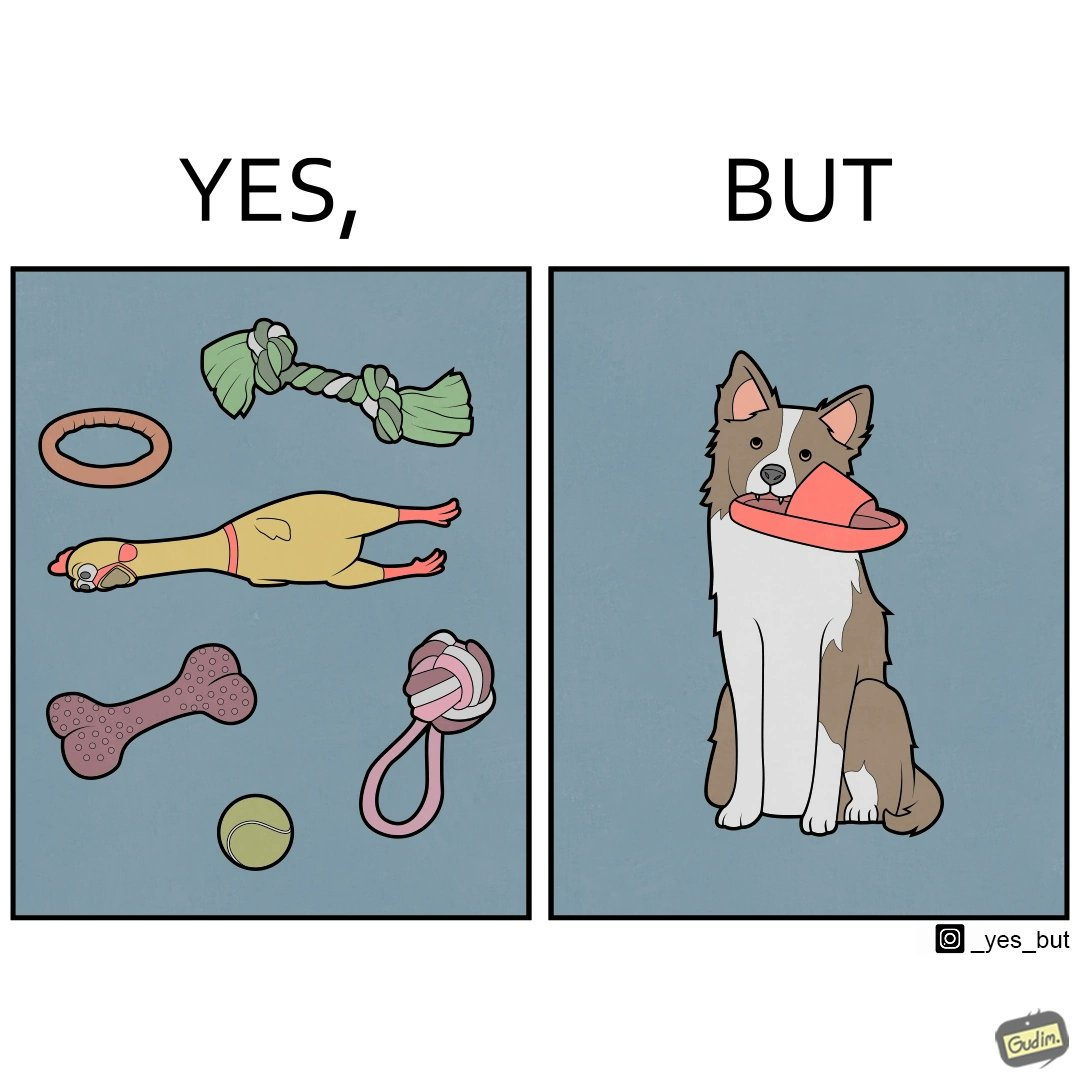What is shown in the left half versus the right half of this image? In the left part of the image: a bunch of toys. In the right part of the image: a dog holding a slipper in its mouth. 